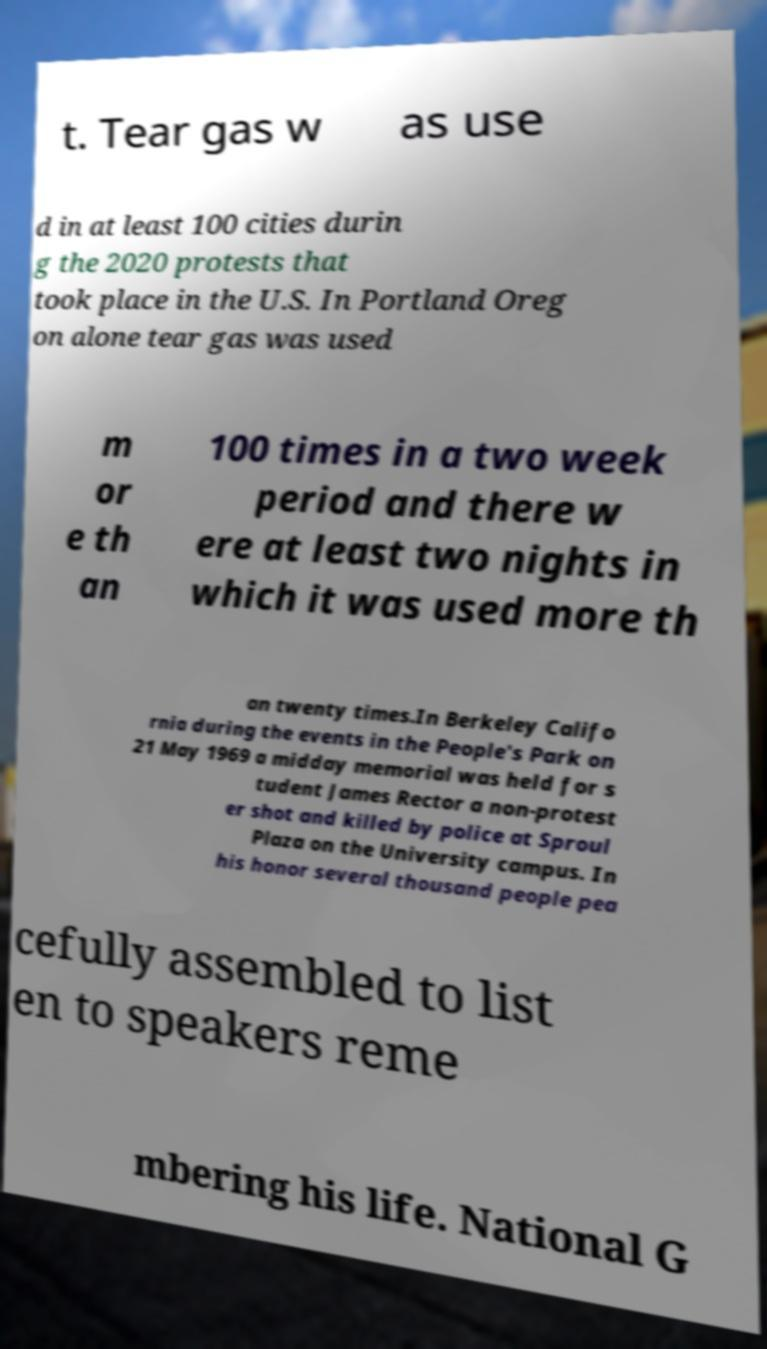Can you read and provide the text displayed in the image?This photo seems to have some interesting text. Can you extract and type it out for me? t. Tear gas w as use d in at least 100 cities durin g the 2020 protests that took place in the U.S. In Portland Oreg on alone tear gas was used m or e th an 100 times in a two week period and there w ere at least two nights in which it was used more th an twenty times.In Berkeley Califo rnia during the events in the People's Park on 21 May 1969 a midday memorial was held for s tudent James Rector a non-protest er shot and killed by police at Sproul Plaza on the University campus. In his honor several thousand people pea cefully assembled to list en to speakers reme mbering his life. National G 